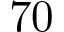<formula> <loc_0><loc_0><loc_500><loc_500>7 0</formula> 